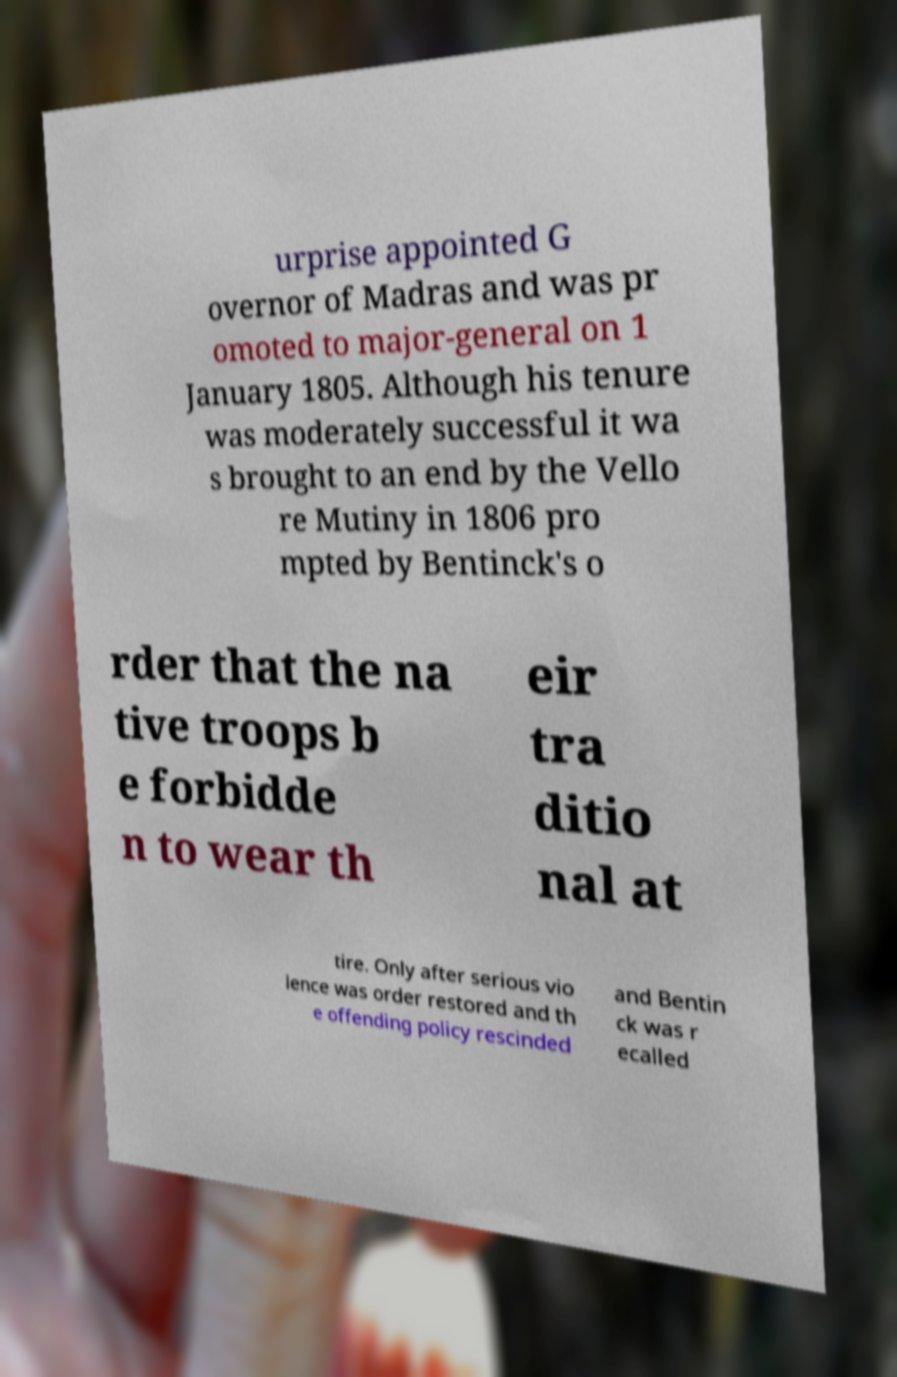For documentation purposes, I need the text within this image transcribed. Could you provide that? urprise appointed G overnor of Madras and was pr omoted to major-general on 1 January 1805. Although his tenure was moderately successful it wa s brought to an end by the Vello re Mutiny in 1806 pro mpted by Bentinck's o rder that the na tive troops b e forbidde n to wear th eir tra ditio nal at tire. Only after serious vio lence was order restored and th e offending policy rescinded and Bentin ck was r ecalled 